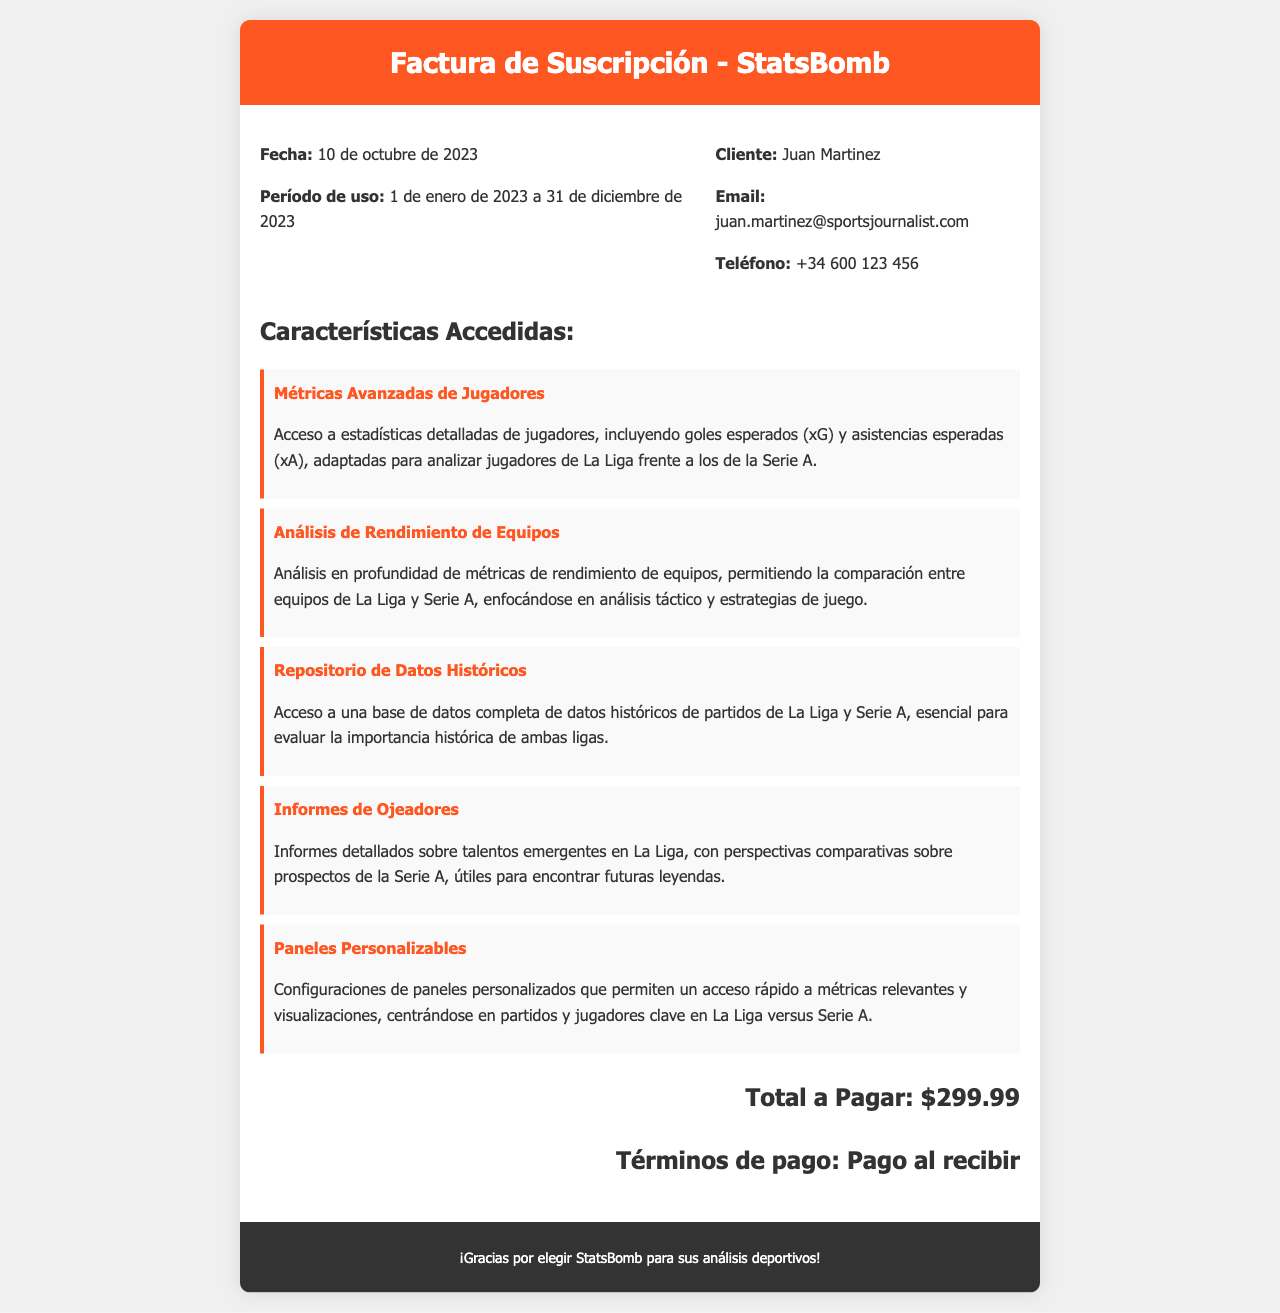¿Qué fecha se indica en la factura? La fecha se menciona en la sección de detalles de la factura.
Answer: 10 de octubre de 2023 ¿Cuál es el período de uso de la suscripción? El período de uso también se encuentra en la sección de detalles de la factura, especificando las fechas de inicio y fin.
Answer: 1 de enero de 2023 a 31 de diciembre de 2023 ¿Quién es el cliente mencionado en la factura? El nombre del cliente está listado en la sección de detalles de la factura.
Answer: Juan Martinez ¿Cuál es el total a pagar por la suscripción? El total a pagar se encuentra en la parte inferior de la sección de la factura, resaltado como el monto total.
Answer: $299.99 ¿Qué característica permite el acceso a métricas de rendimiento de equipos? Esta información se extrae de la lista de características accedidas en la factura.
Answer: Análisis de Rendimiento de Equipos ¿Cuál es el propósito del Repositorio de Datos Históricos? El propósito se menciona en la descripción de la característica en la factura.
Answer: Evaluar la importancia histórica de ambas ligas ¿A qué liga están adaptadas las métricas avanzadas de jugadores? La respuesta se encuentra en la descripción de la característica en la factura.
Answer: La Liga ¿Cuál es el método de pago indicado en la factura? El método de pago se menciona al final de la factura, justo antes del agradecimiento.
Answer: Pago al recibir 